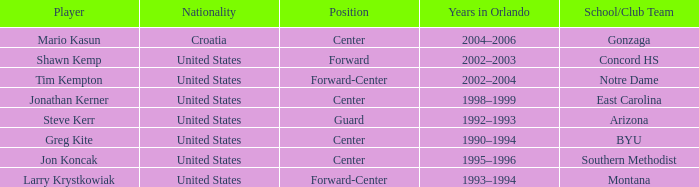What years in Orlando have the United States as the nationality, with concord hs as the school/club team? 2002–2003. 